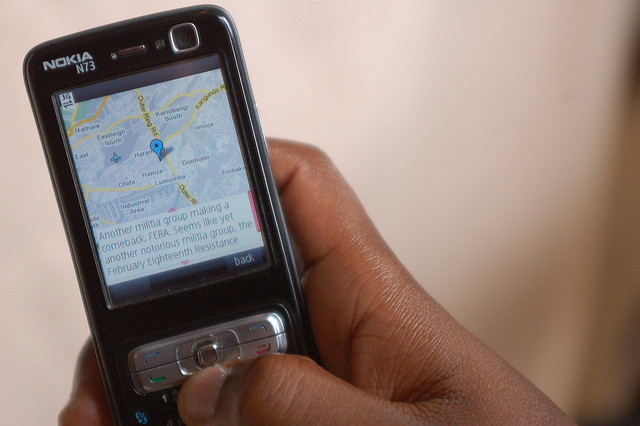Please transcribe the text information in this image. NOKIA N73 Another group Eighteenth Resistance group notonous another me yet Seems combed FERA making 